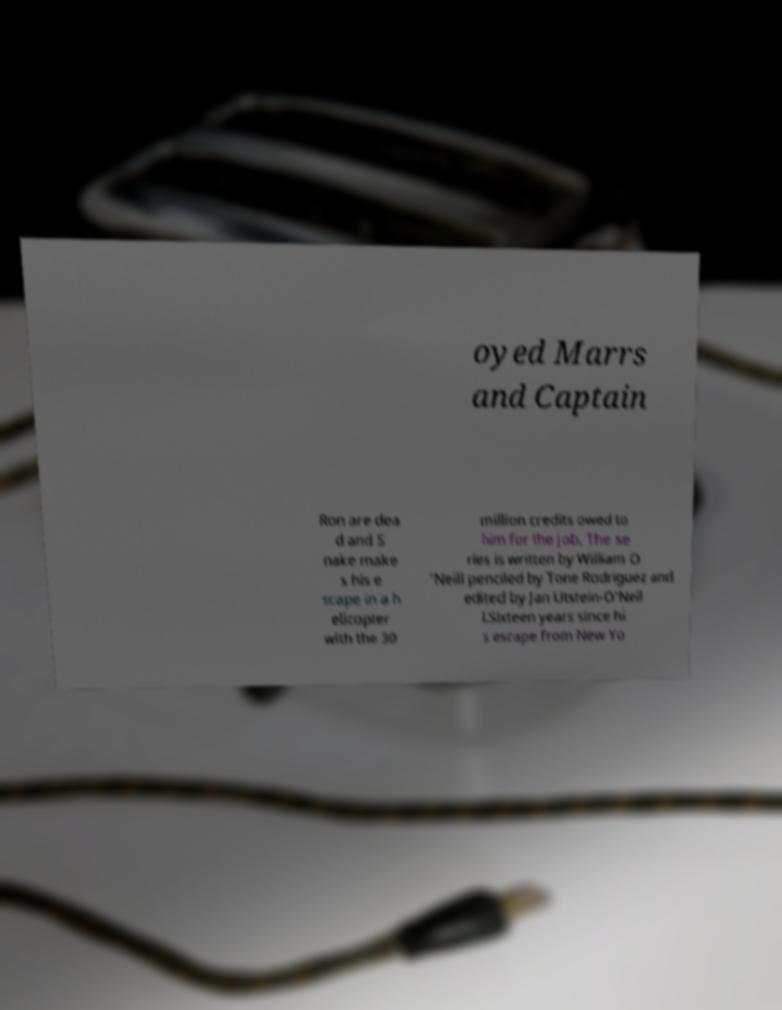Please read and relay the text visible in this image. What does it say? oyed Marrs and Captain Ron are dea d and S nake make s his e scape in a h elicopter with the 30 million credits owed to him for the job. The se ries is written by William O 'Neill penciled by Tone Rodriguez and edited by Jan Utstein-O'Neil l.Sixteen years since hi s escape from New Yo 